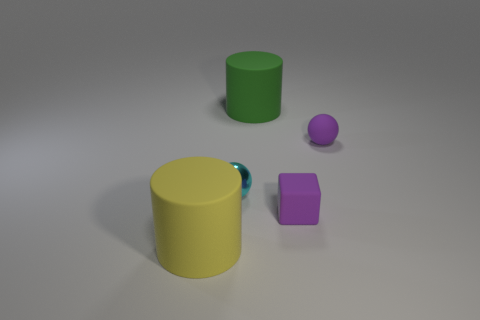Do the sphere that is to the left of the green matte cylinder and the big object in front of the large green cylinder have the same material?
Provide a short and direct response. No. There is a purple ball that is the same size as the purple cube; what is it made of?
Keep it short and to the point. Rubber. Do the cyan thing and the large yellow cylinder have the same material?
Your answer should be very brief. No. Is there a tiny purple thing of the same shape as the small cyan shiny thing?
Keep it short and to the point. Yes. Is there another rubber object of the same size as the green thing?
Your answer should be compact. Yes. What number of green rubber cylinders are there?
Your answer should be compact. 1. How many big things are yellow matte things or green cubes?
Provide a succinct answer. 1. There is a large object on the right side of the large rubber cylinder in front of the small rubber thing right of the tiny rubber block; what is its color?
Your answer should be very brief. Green. What number of other objects are there of the same color as the matte sphere?
Your answer should be very brief. 1. What number of shiny objects are big purple spheres or big green cylinders?
Your response must be concise. 0. 